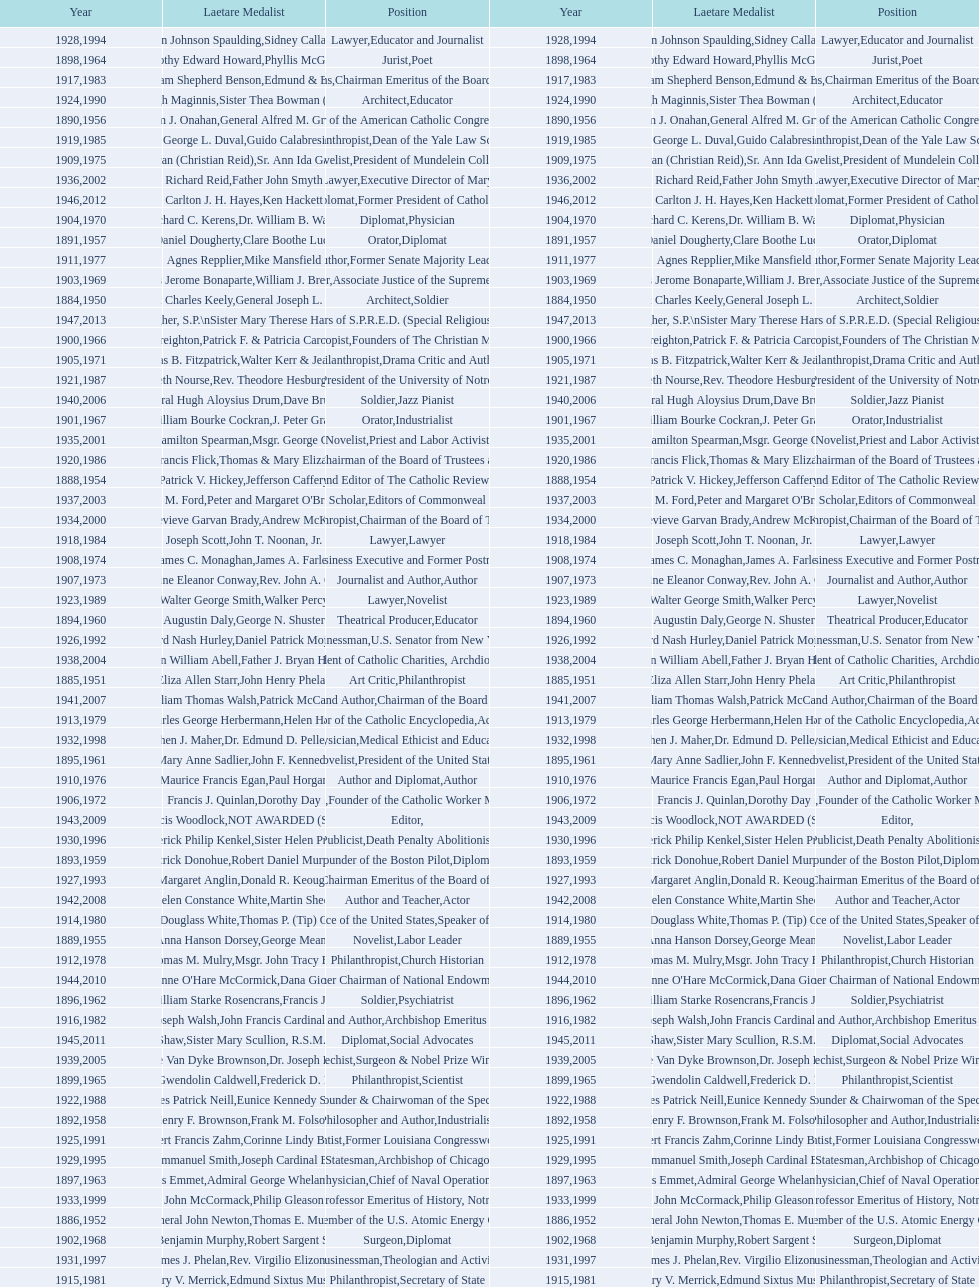How many lawyers have won the award between 1883 and 2014? 5. 